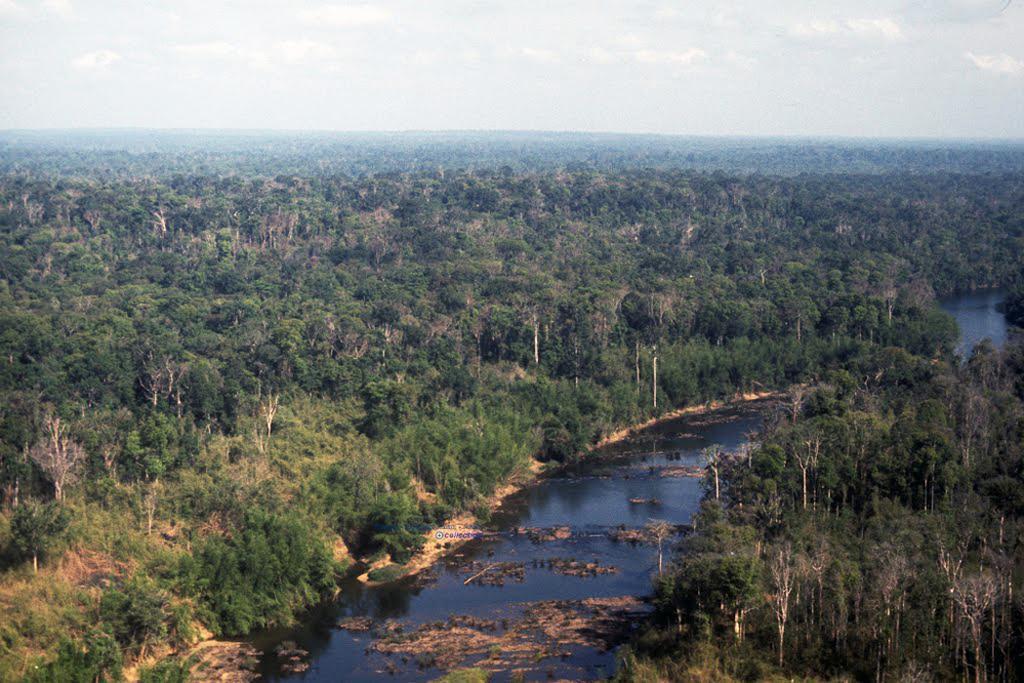How would you summarize this image in a sentence or two? In the background we can see sky with clouds. This picture is full of greenery with trees. Here we can see water. 